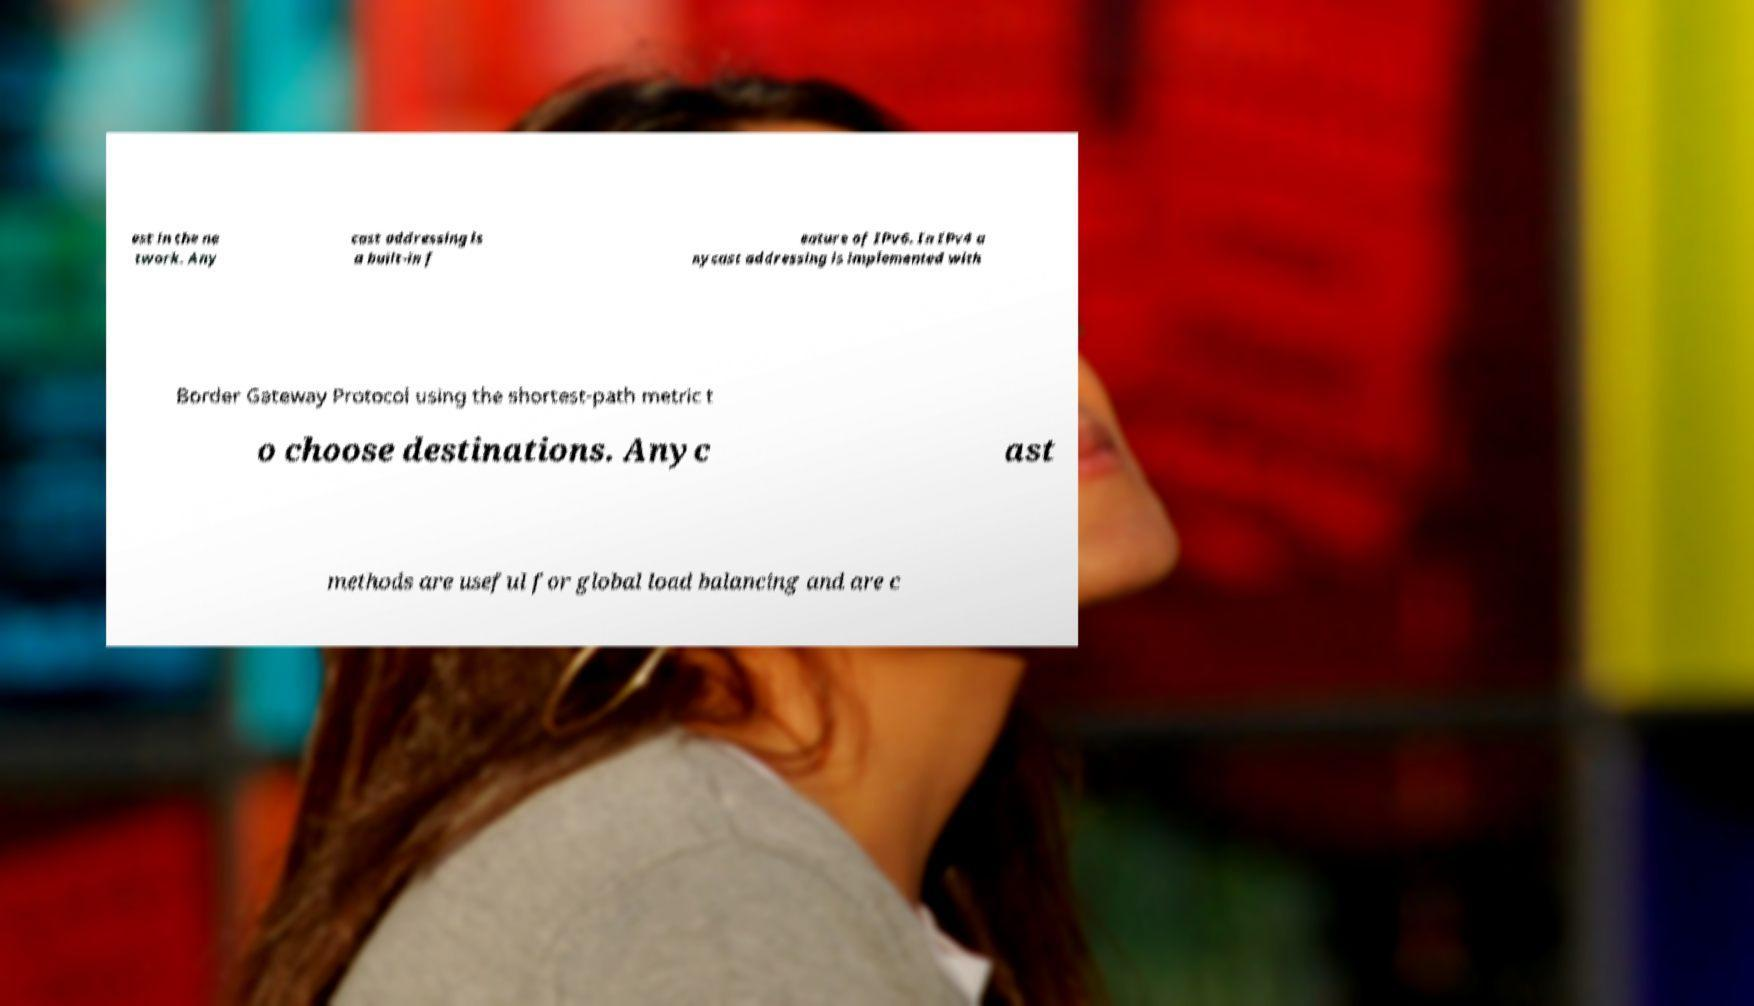Can you read and provide the text displayed in the image?This photo seems to have some interesting text. Can you extract and type it out for me? est in the ne twork. Any cast addressing is a built-in f eature of IPv6. In IPv4 a nycast addressing is implemented with Border Gateway Protocol using the shortest-path metric t o choose destinations. Anyc ast methods are useful for global load balancing and are c 